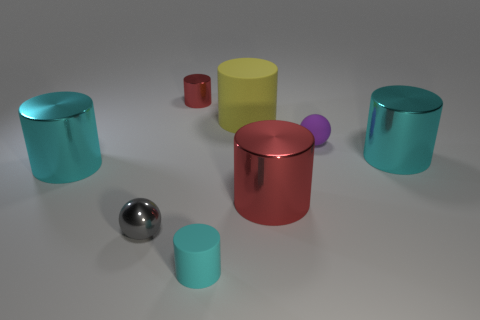What texture do the objects in the image seem to have? The objects in the image appear to have a smooth and glossy texture. The reflection and glossiness hint that the materials could be metallic or plastic, giving them a sleek and polished look. Various light sources are being reflected differently, indicating variations in curvature and smoothness. Do any of the objects appear transparent or translucent? None of the objects in the image appear to be transparent or translucent; all objects have an opaque quality with reflective surfaces that suggest solidity. 